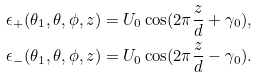<formula> <loc_0><loc_0><loc_500><loc_500>\epsilon _ { + } ( \theta _ { 1 } , \theta , \phi , z ) & = U _ { 0 } \cos ( 2 \pi \frac { z } { d } + \gamma _ { 0 } ) , \\ \epsilon _ { - } ( \theta _ { 1 } , \theta , \phi , z ) & = U _ { 0 } \cos ( 2 \pi \frac { z } { d } - \gamma _ { 0 } ) . \</formula> 